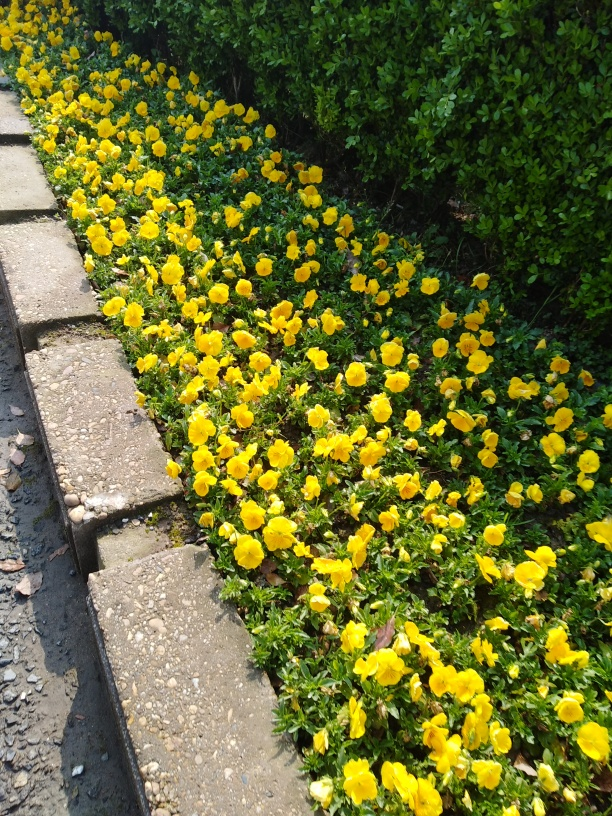Is the background clear in the image? The background contains a partial view of a dense shrubbery. Although it isn't the main focus, the shrubs are quite discernable and complement the vibrant yellow flowers in the foreground. 